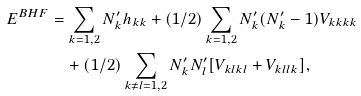<formula> <loc_0><loc_0><loc_500><loc_500>E ^ { B H F } & = \sum _ { k = 1 , 2 } N ^ { \prime } _ { k } h _ { k k } + ( 1 / 2 ) \sum _ { k = 1 , 2 } N ^ { \prime } _ { k } ( N ^ { \prime } _ { k } - 1 ) V _ { k k k k } \\ & \quad + ( 1 / 2 ) \sum _ { k \neq l = 1 , 2 } N ^ { \prime } _ { k } N ^ { \prime } _ { l } [ V _ { k l k l } + V _ { k l l k } ] ,</formula> 